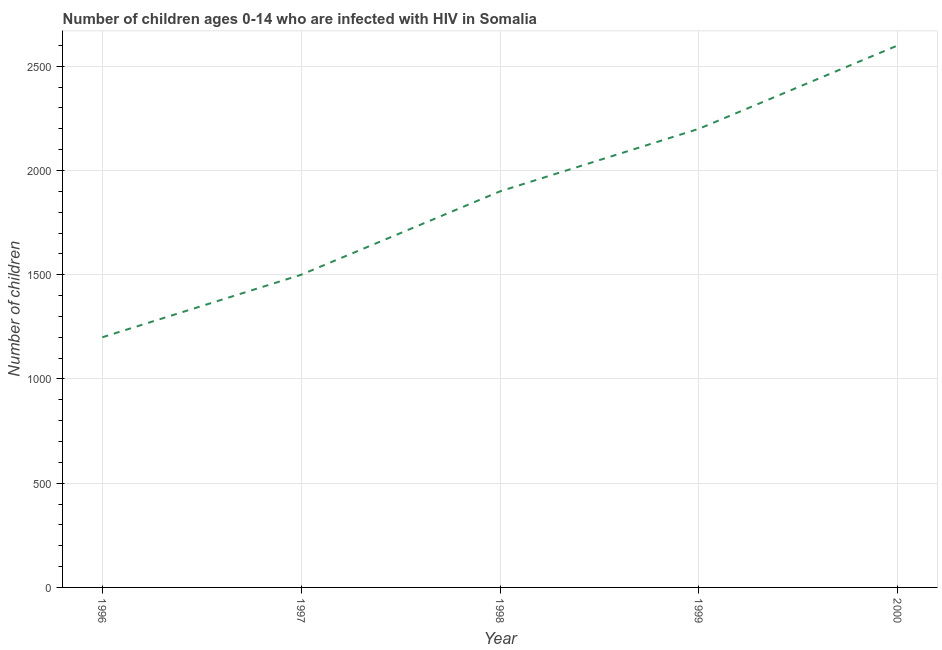What is the number of children living with hiv in 1998?
Provide a short and direct response. 1900. Across all years, what is the maximum number of children living with hiv?
Your response must be concise. 2600. Across all years, what is the minimum number of children living with hiv?
Offer a very short reply. 1200. What is the sum of the number of children living with hiv?
Ensure brevity in your answer.  9400. What is the difference between the number of children living with hiv in 1997 and 1999?
Provide a succinct answer. -700. What is the average number of children living with hiv per year?
Provide a succinct answer. 1880. What is the median number of children living with hiv?
Your response must be concise. 1900. In how many years, is the number of children living with hiv greater than 2200 ?
Your answer should be very brief. 1. Do a majority of the years between 1996 and 1997 (inclusive) have number of children living with hiv greater than 400 ?
Provide a succinct answer. Yes. What is the ratio of the number of children living with hiv in 1997 to that in 1999?
Provide a short and direct response. 0.68. Is the number of children living with hiv in 1997 less than that in 1998?
Offer a terse response. Yes. What is the difference between the highest and the second highest number of children living with hiv?
Give a very brief answer. 400. What is the difference between the highest and the lowest number of children living with hiv?
Provide a succinct answer. 1400. How many lines are there?
Give a very brief answer. 1. What is the difference between two consecutive major ticks on the Y-axis?
Your response must be concise. 500. What is the title of the graph?
Your answer should be compact. Number of children ages 0-14 who are infected with HIV in Somalia. What is the label or title of the X-axis?
Give a very brief answer. Year. What is the label or title of the Y-axis?
Provide a short and direct response. Number of children. What is the Number of children of 1996?
Your response must be concise. 1200. What is the Number of children of 1997?
Offer a terse response. 1500. What is the Number of children of 1998?
Your answer should be very brief. 1900. What is the Number of children in 1999?
Your answer should be very brief. 2200. What is the Number of children in 2000?
Provide a succinct answer. 2600. What is the difference between the Number of children in 1996 and 1997?
Give a very brief answer. -300. What is the difference between the Number of children in 1996 and 1998?
Your response must be concise. -700. What is the difference between the Number of children in 1996 and 1999?
Make the answer very short. -1000. What is the difference between the Number of children in 1996 and 2000?
Make the answer very short. -1400. What is the difference between the Number of children in 1997 and 1998?
Give a very brief answer. -400. What is the difference between the Number of children in 1997 and 1999?
Offer a very short reply. -700. What is the difference between the Number of children in 1997 and 2000?
Make the answer very short. -1100. What is the difference between the Number of children in 1998 and 1999?
Your answer should be compact. -300. What is the difference between the Number of children in 1998 and 2000?
Provide a succinct answer. -700. What is the difference between the Number of children in 1999 and 2000?
Your answer should be very brief. -400. What is the ratio of the Number of children in 1996 to that in 1998?
Provide a succinct answer. 0.63. What is the ratio of the Number of children in 1996 to that in 1999?
Your response must be concise. 0.55. What is the ratio of the Number of children in 1996 to that in 2000?
Your response must be concise. 0.46. What is the ratio of the Number of children in 1997 to that in 1998?
Keep it short and to the point. 0.79. What is the ratio of the Number of children in 1997 to that in 1999?
Keep it short and to the point. 0.68. What is the ratio of the Number of children in 1997 to that in 2000?
Make the answer very short. 0.58. What is the ratio of the Number of children in 1998 to that in 1999?
Keep it short and to the point. 0.86. What is the ratio of the Number of children in 1998 to that in 2000?
Provide a succinct answer. 0.73. What is the ratio of the Number of children in 1999 to that in 2000?
Your answer should be very brief. 0.85. 